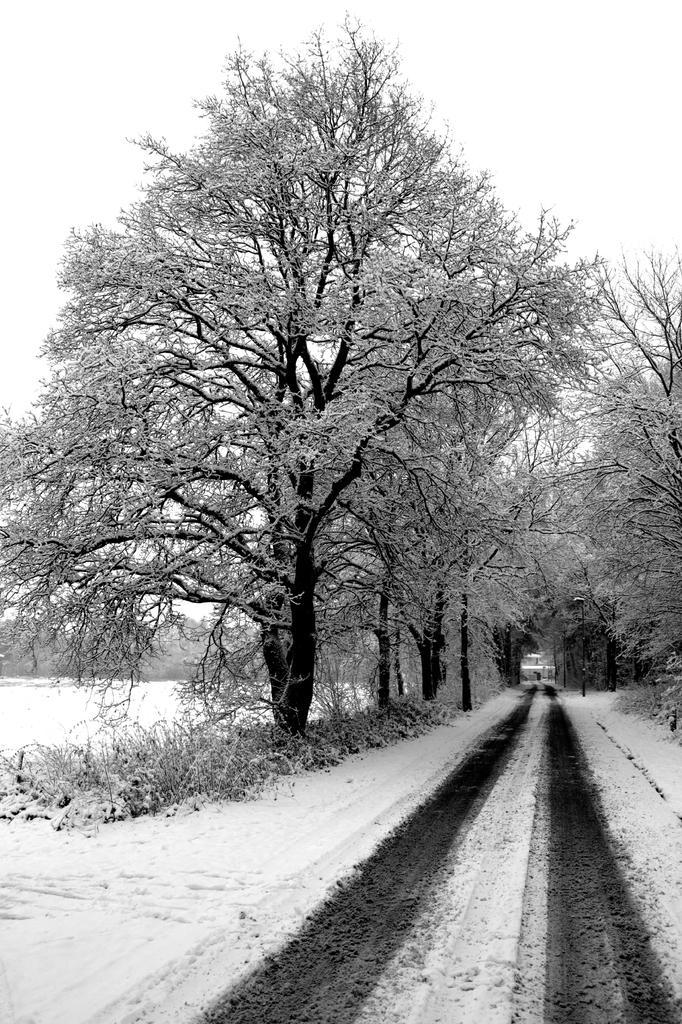Could you give a brief overview of what you see in this image? In this picture I can see there is a road here and there is a tree here on to the left of the road and there are some plants here and they are also covered with snow. 